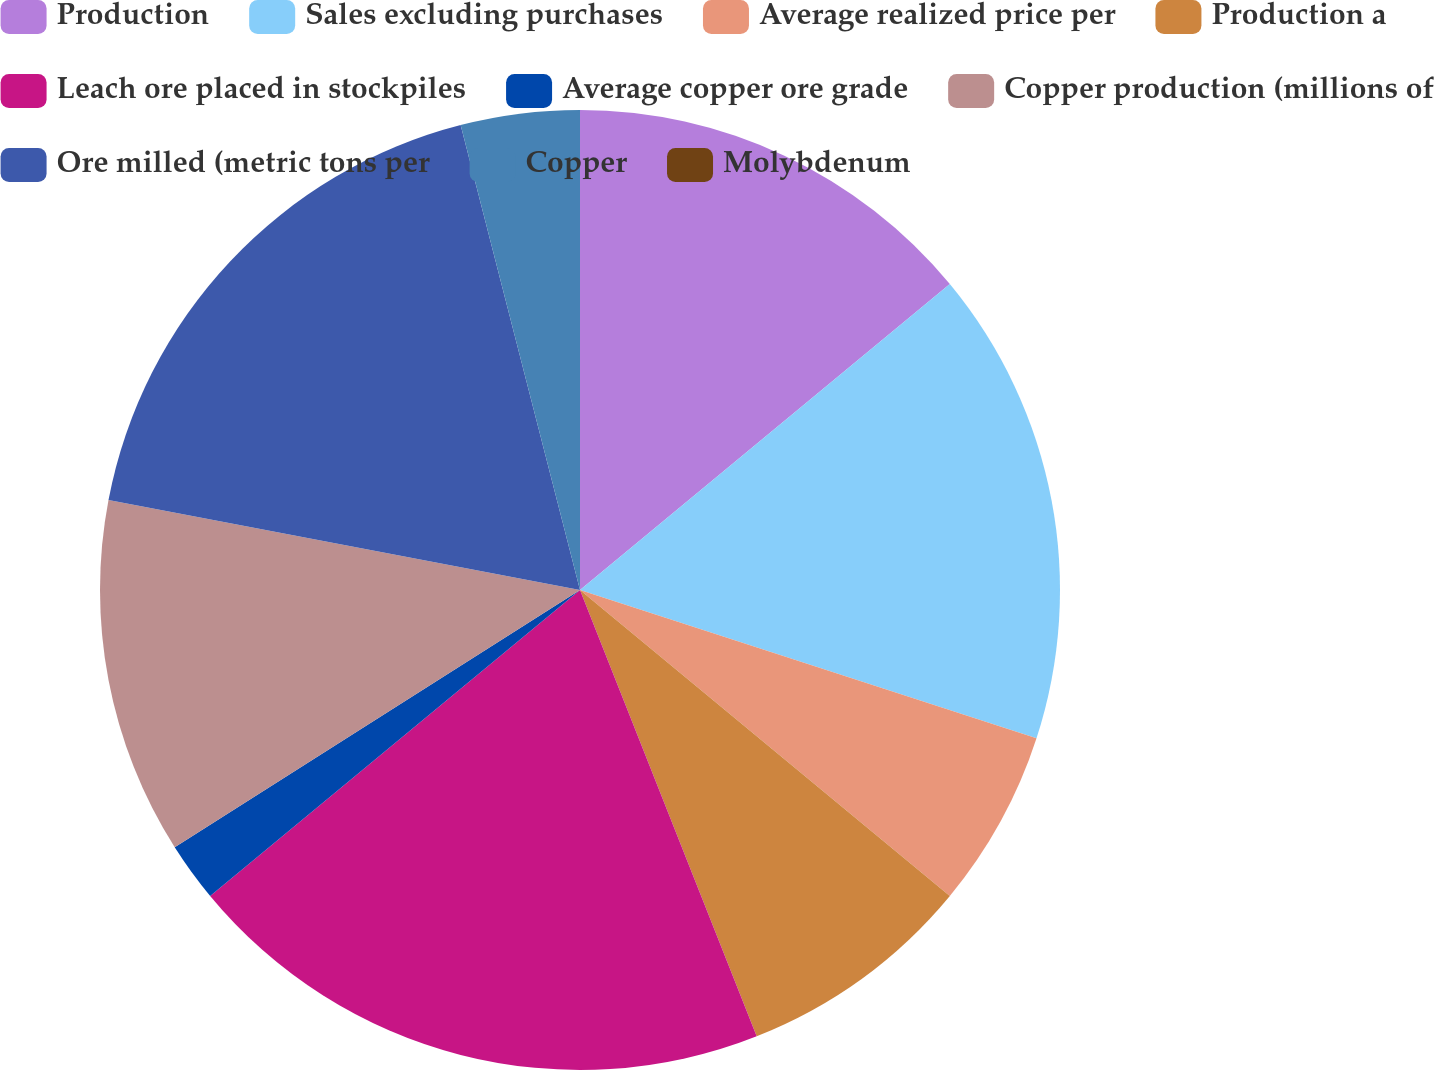Convert chart. <chart><loc_0><loc_0><loc_500><loc_500><pie_chart><fcel>Production<fcel>Sales excluding purchases<fcel>Average realized price per<fcel>Production a<fcel>Leach ore placed in stockpiles<fcel>Average copper ore grade<fcel>Copper production (millions of<fcel>Ore milled (metric tons per<fcel>Copper<fcel>Molybdenum<nl><fcel>14.0%<fcel>16.0%<fcel>6.0%<fcel>8.0%<fcel>20.0%<fcel>2.0%<fcel>12.0%<fcel>18.0%<fcel>4.0%<fcel>0.0%<nl></chart> 